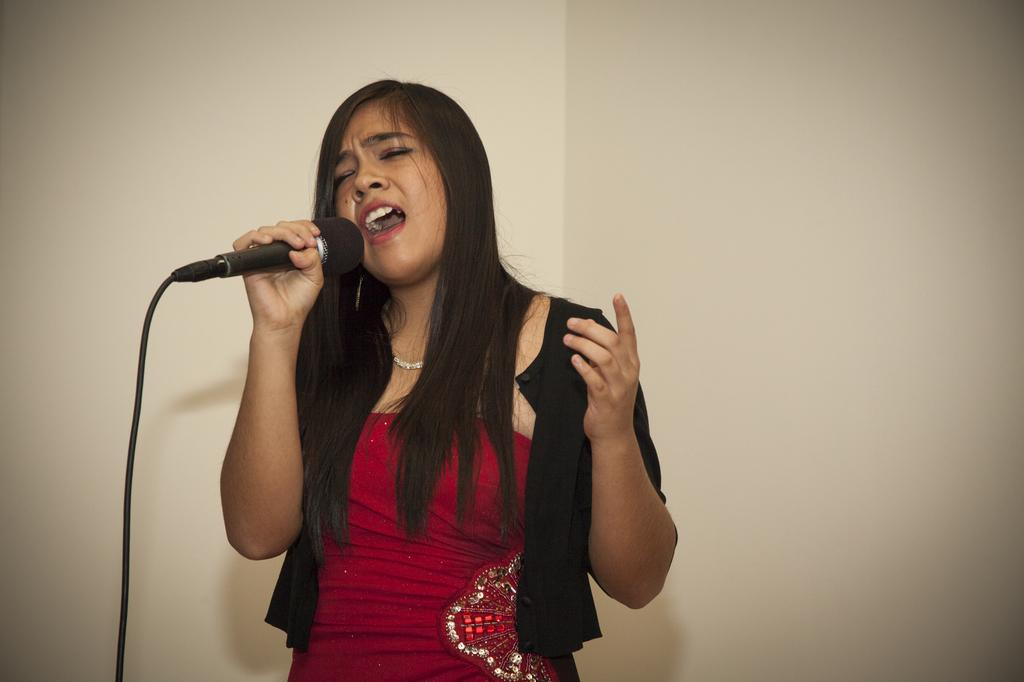What is the main subject of the image? There is a woman in the image. What is the woman doing in the image? The woman is standing and singing. What object is the woman holding in her hand? The woman is holding a microphone in her hand. What can be seen behind the woman in the image? There is a wall behind the woman. How does the woman compare to the twig in the image? There is no twig present in the image, so it is not possible to make a comparison. 